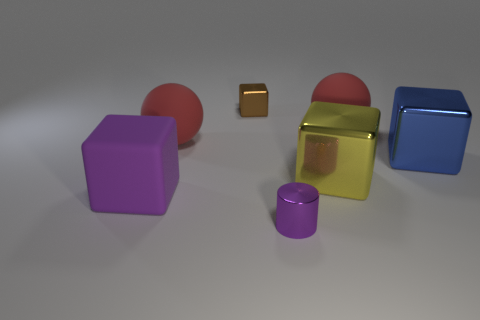What is the material of the large purple object that is the same shape as the large yellow metal object?
Your response must be concise. Rubber. How many yellow blocks have the same size as the blue metallic object?
Give a very brief answer. 1. How many purple things are there?
Offer a terse response. 2. Are the purple cylinder and the large red ball that is to the left of the tiny brown thing made of the same material?
Provide a succinct answer. No. What number of blue objects are large objects or tiny shiny cubes?
Make the answer very short. 1. What is the size of the brown cube that is the same material as the blue object?
Offer a terse response. Small. How many tiny brown shiny objects are the same shape as the big blue object?
Give a very brief answer. 1. Is the number of big matte objects to the left of the large blue metal block greater than the number of metal objects that are right of the yellow block?
Give a very brief answer. Yes. Does the large rubber cube have the same color as the small block that is to the right of the matte block?
Provide a succinct answer. No. There is a purple object that is the same size as the blue object; what material is it?
Give a very brief answer. Rubber. 